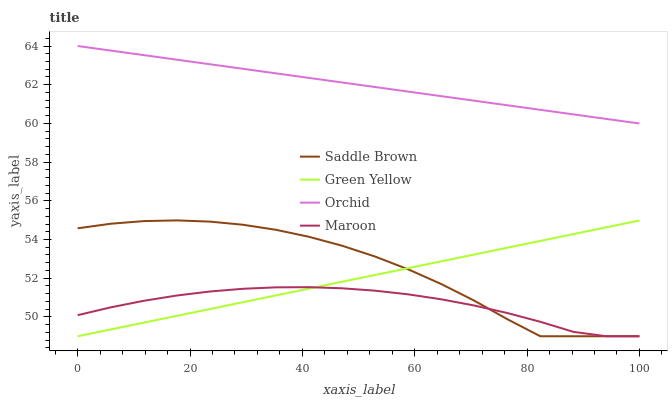Does Maroon have the minimum area under the curve?
Answer yes or no. Yes. Does Orchid have the maximum area under the curve?
Answer yes or no. Yes. Does Saddle Brown have the minimum area under the curve?
Answer yes or no. No. Does Saddle Brown have the maximum area under the curve?
Answer yes or no. No. Is Green Yellow the smoothest?
Answer yes or no. Yes. Is Saddle Brown the roughest?
Answer yes or no. Yes. Is Maroon the smoothest?
Answer yes or no. No. Is Maroon the roughest?
Answer yes or no. No. Does Green Yellow have the lowest value?
Answer yes or no. Yes. Does Orchid have the lowest value?
Answer yes or no. No. Does Orchid have the highest value?
Answer yes or no. Yes. Does Saddle Brown have the highest value?
Answer yes or no. No. Is Maroon less than Orchid?
Answer yes or no. Yes. Is Orchid greater than Saddle Brown?
Answer yes or no. Yes. Does Maroon intersect Green Yellow?
Answer yes or no. Yes. Is Maroon less than Green Yellow?
Answer yes or no. No. Is Maroon greater than Green Yellow?
Answer yes or no. No. Does Maroon intersect Orchid?
Answer yes or no. No. 